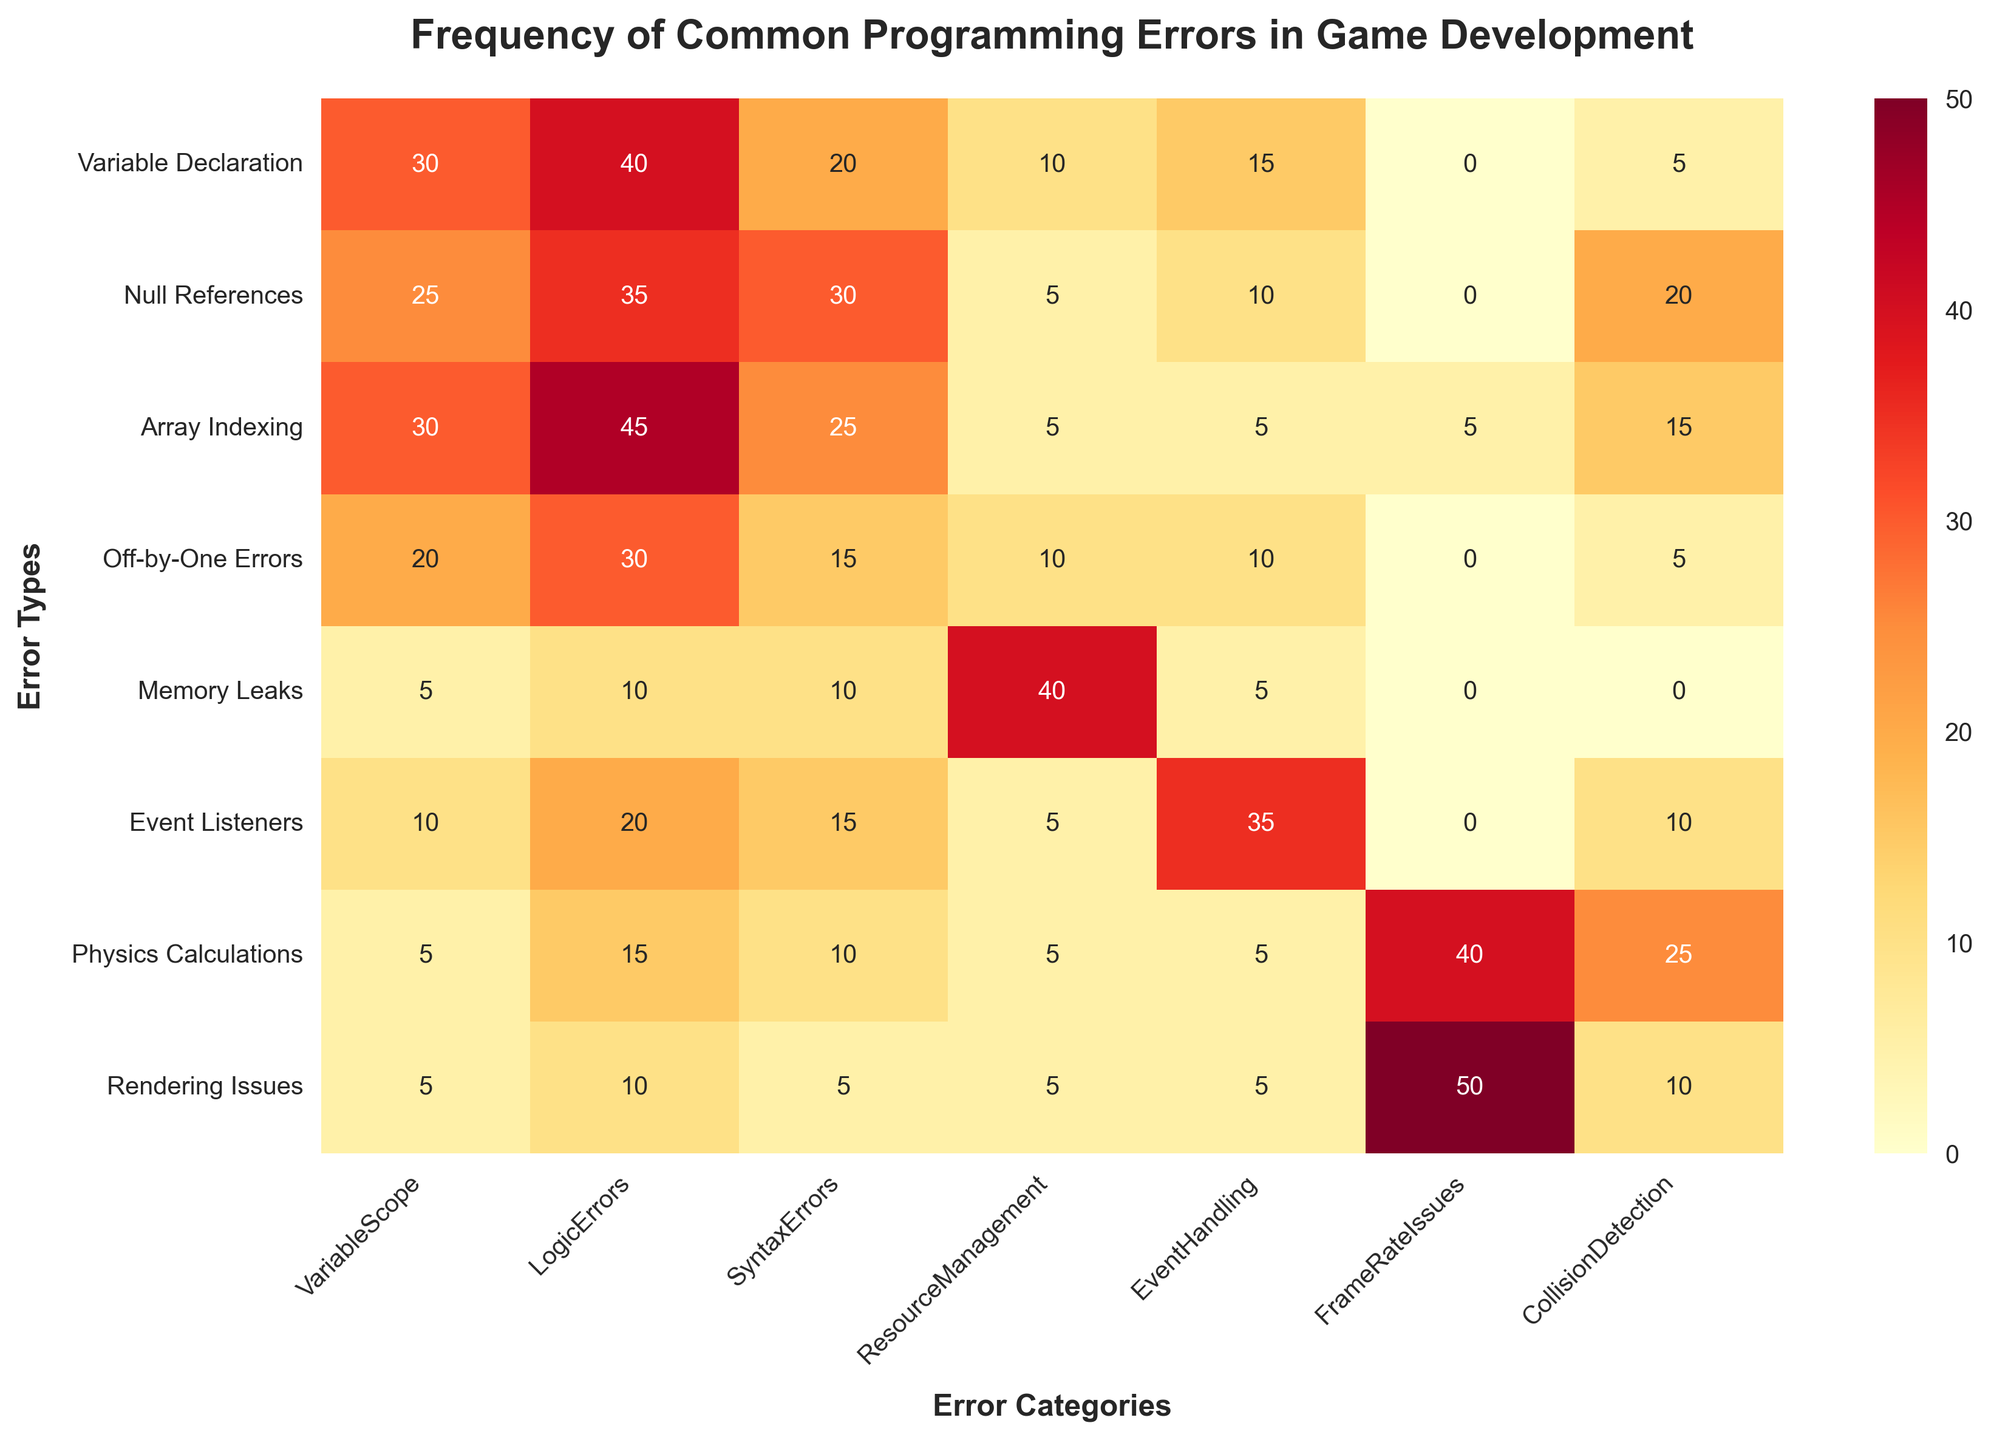How does the frequency of Logic Errors for "Variable Declaration" compare with "Array Indexing"? First, identify the frequency of Logic Errors for each error type from the figure. "Variable Declaration" has a frequency of 40, and "Array Indexing" has a frequency of 45. Comparing these, 45 is higher than 40.
Answer: "Array Indexing" has a higher frequency Which error type has the highest frequency of issues related to EventHandling? Look at the EventHandling column and find the highest value. Event Listeners have a frequency of 35 for EventHandling.
Answer: Event Listeners What is the total frequency of Syntax Errors for "Null References" and "Physics Calculations"? Identify the frequency of Syntax Errors for both error types. "Null References" has a frequency of 35, and "Physics Calculations" has a frequency of 15. Adding them together, 35 + 15 = 50.
Answer: 50 Between "Memory Leaks" and "Rendering Issues," which has a higher frequency of FrameRateIssues? Look at the FrameRateIssues column for both error types. "Memory Leaks" has a frequency of 0, and "Rendering Issues" has a frequency of 50. Clearly, 50 is higher than 0.
Answer: Rendering Issues What is the overall frequency of ResourceManagement issues across all error types? Sum the values in the ResourceManagement column: 10 (Variable Declaration) + 5 (Null References) + 5 (Array Indexing) + 10 (Off-by-One Errors) + 40 (Memory Leaks) + 5 (Event Listeners) + 5 (Physics Calculations) + 5 (Rendering Issues) = 85.
Answer: 85 Which error type has the largest disparity between the frequencies of LogicErrors and VariableScope? Calculate the differences between LogicErrors and VariableScope for each error type. "Variable Declaration" (40 - 30 = 10), "Null References" (30 - 25 = 5), "Array Indexing" (25 - 30 = -5), "Off-by-One Errors" (15 - 20 = -5), "Memory Leaks" (10 - 5 = 5), "Event Listeners" (15 - 10 = 5), "Physics Calculations" (10 - 5 = 5), "Rendering Issues" (5 - 5 = 0). The largest disparity is 10.
Answer: Variable Declaration What is the frequency difference between the highest and lowest values in the CollisionDetection column? Identify the highest and lowest values in the CollisionDetection column (25 for Physics Calculations and 0 for multiple error types). The difference is 25 - 0 = 25.
Answer: 25 Which error types have an equal frequency of VariableScope issues? Identify the VariableScope frequencies and see which ones are equal. "Null References" and "Off-by-One Errors" both have a frequency of 20. "Memory Leaks" and "Physics Calculations" both have a frequency of 5.
Answer: Null References and Off-by-One Errors; Memory Leaks and Physics Calculations 